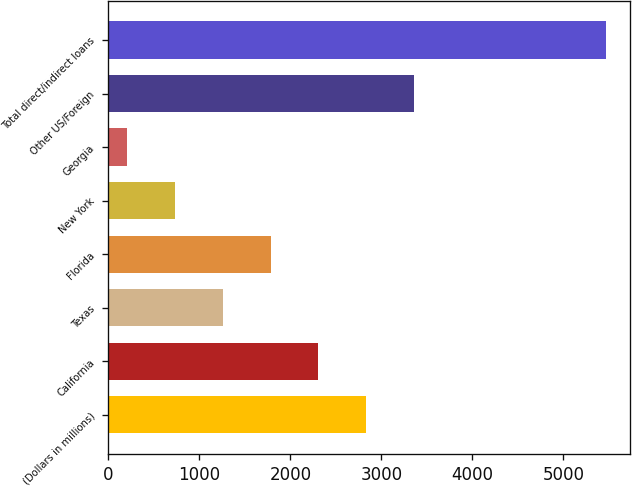Convert chart. <chart><loc_0><loc_0><loc_500><loc_500><bar_chart><fcel>(Dollars in millions)<fcel>California<fcel>Texas<fcel>Florida<fcel>New York<fcel>Georgia<fcel>Other US/Foreign<fcel>Total direct/indirect loans<nl><fcel>2834<fcel>2308.2<fcel>1256.6<fcel>1782.4<fcel>730.8<fcel>205<fcel>3359.8<fcel>5463<nl></chart> 